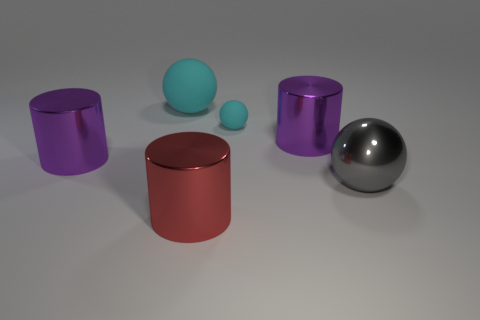What material is the ball that is the same size as the gray thing?
Your answer should be very brief. Rubber. Are there the same number of large rubber spheres that are on the right side of the gray shiny thing and red metallic cylinders that are on the right side of the red shiny cylinder?
Provide a succinct answer. Yes. How many tiny objects are behind the purple cylinder that is on the right side of the metallic cylinder in front of the gray object?
Offer a very short reply. 1. There is a big metallic ball; is its color the same as the big cylinder that is left of the red metallic object?
Your answer should be compact. No. There is another sphere that is the same material as the small ball; what is its size?
Offer a very short reply. Large. Is the number of gray spheres that are to the right of the red object greater than the number of blue rubber cylinders?
Make the answer very short. Yes. What material is the small cyan ball right of the shiny cylinder in front of the metal cylinder left of the large red cylinder made of?
Your response must be concise. Rubber. Does the small ball have the same material as the ball that is to the left of the red thing?
Give a very brief answer. Yes. What material is the big gray thing that is the same shape as the large cyan rubber thing?
Keep it short and to the point. Metal. Is there anything else that is made of the same material as the big cyan ball?
Your answer should be very brief. Yes. 